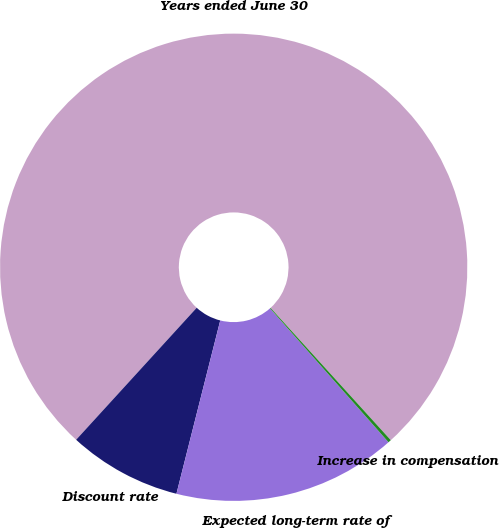Convert chart. <chart><loc_0><loc_0><loc_500><loc_500><pie_chart><fcel>Years ended June 30<fcel>Discount rate<fcel>Expected long-term rate of<fcel>Increase in compensation<nl><fcel>76.49%<fcel>7.84%<fcel>15.47%<fcel>0.21%<nl></chart> 